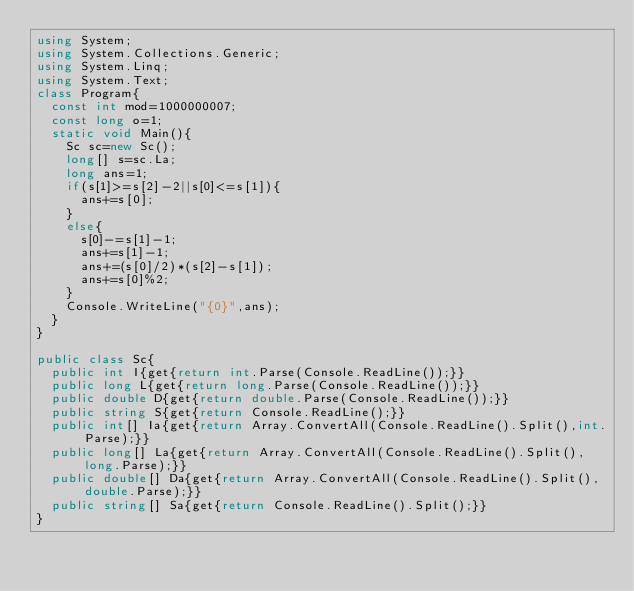<code> <loc_0><loc_0><loc_500><loc_500><_C#_>using System;
using System.Collections.Generic;
using System.Linq;
using System.Text;
class Program{
	const int mod=1000000007;
	const long o=1;
	static void Main(){
		Sc sc=new Sc();
		long[] s=sc.La;
		long ans=1;
		if(s[1]>=s[2]-2||s[0]<=s[1]){
			ans+=s[0];
		}
		else{
			s[0]-=s[1]-1;
			ans+=s[1]-1;
			ans+=(s[0]/2)*(s[2]-s[1]);
			ans+=s[0]%2;
		}
		Console.WriteLine("{0}",ans);
	}
}

public class Sc{
	public int I{get{return int.Parse(Console.ReadLine());}}
	public long L{get{return long.Parse(Console.ReadLine());}}
	public double D{get{return double.Parse(Console.ReadLine());}}
	public string S{get{return Console.ReadLine();}}
	public int[] Ia{get{return Array.ConvertAll(Console.ReadLine().Split(),int.Parse);}}
	public long[] La{get{return Array.ConvertAll(Console.ReadLine().Split(),long.Parse);}}
	public double[] Da{get{return Array.ConvertAll(Console.ReadLine().Split(),double.Parse);}}
	public string[] Sa{get{return Console.ReadLine().Split();}}
}</code> 